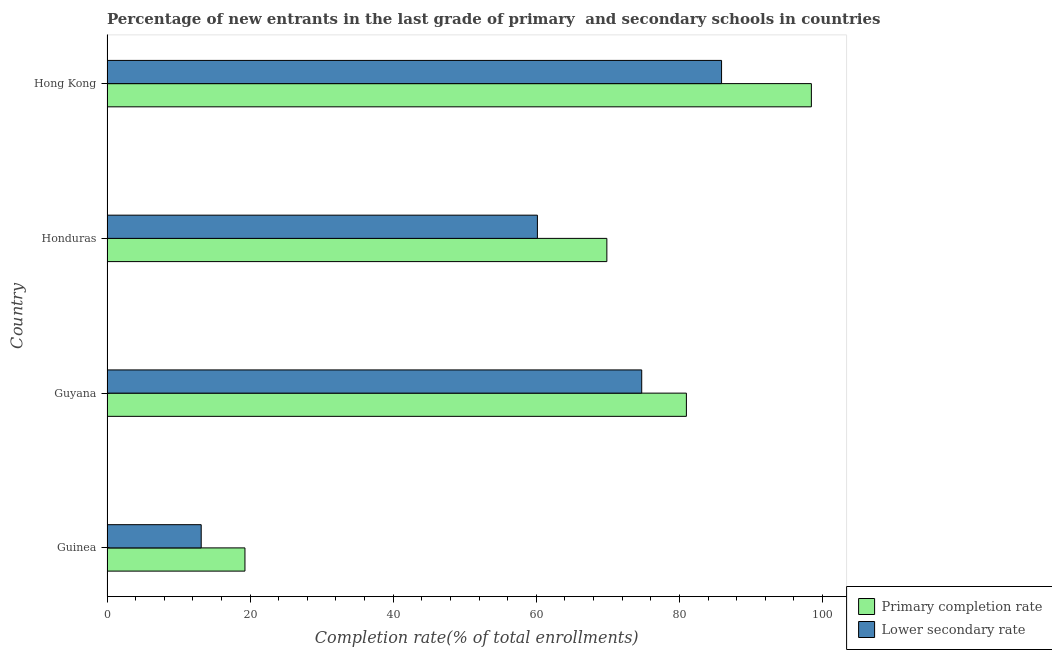How many groups of bars are there?
Offer a terse response. 4. Are the number of bars per tick equal to the number of legend labels?
Keep it short and to the point. Yes. Are the number of bars on each tick of the Y-axis equal?
Your answer should be compact. Yes. What is the label of the 1st group of bars from the top?
Offer a very short reply. Hong Kong. What is the completion rate in secondary schools in Guinea?
Your answer should be very brief. 13.16. Across all countries, what is the maximum completion rate in secondary schools?
Give a very brief answer. 85.88. Across all countries, what is the minimum completion rate in primary schools?
Provide a short and direct response. 19.28. In which country was the completion rate in secondary schools maximum?
Your answer should be very brief. Hong Kong. In which country was the completion rate in primary schools minimum?
Your response must be concise. Guinea. What is the total completion rate in secondary schools in the graph?
Your response must be concise. 233.92. What is the difference between the completion rate in primary schools in Guyana and that in Hong Kong?
Offer a very short reply. -17.46. What is the difference between the completion rate in secondary schools in Hong Kong and the completion rate in primary schools in Guinea?
Ensure brevity in your answer.  66.61. What is the average completion rate in secondary schools per country?
Your response must be concise. 58.48. What is the difference between the completion rate in secondary schools and completion rate in primary schools in Guyana?
Ensure brevity in your answer.  -6.24. What is the ratio of the completion rate in secondary schools in Honduras to that in Hong Kong?
Your response must be concise. 0.7. Is the completion rate in secondary schools in Guinea less than that in Hong Kong?
Provide a succinct answer. Yes. What is the difference between the highest and the second highest completion rate in primary schools?
Ensure brevity in your answer.  17.46. What is the difference between the highest and the lowest completion rate in secondary schools?
Offer a very short reply. 72.72. Is the sum of the completion rate in primary schools in Honduras and Hong Kong greater than the maximum completion rate in secondary schools across all countries?
Offer a terse response. Yes. What does the 1st bar from the top in Hong Kong represents?
Offer a very short reply. Lower secondary rate. What does the 1st bar from the bottom in Guinea represents?
Provide a short and direct response. Primary completion rate. How many bars are there?
Your answer should be very brief. 8. Are all the bars in the graph horizontal?
Ensure brevity in your answer.  Yes. How many countries are there in the graph?
Provide a succinct answer. 4. What is the difference between two consecutive major ticks on the X-axis?
Your response must be concise. 20. Are the values on the major ticks of X-axis written in scientific E-notation?
Your answer should be very brief. No. Does the graph contain any zero values?
Your answer should be compact. No. Where does the legend appear in the graph?
Make the answer very short. Bottom right. How are the legend labels stacked?
Offer a very short reply. Vertical. What is the title of the graph?
Your response must be concise. Percentage of new entrants in the last grade of primary  and secondary schools in countries. What is the label or title of the X-axis?
Make the answer very short. Completion rate(% of total enrollments). What is the Completion rate(% of total enrollments) in Primary completion rate in Guinea?
Your answer should be very brief. 19.28. What is the Completion rate(% of total enrollments) in Lower secondary rate in Guinea?
Your response must be concise. 13.16. What is the Completion rate(% of total enrollments) in Primary completion rate in Guyana?
Offer a very short reply. 80.97. What is the Completion rate(% of total enrollments) of Lower secondary rate in Guyana?
Provide a short and direct response. 74.73. What is the Completion rate(% of total enrollments) in Primary completion rate in Honduras?
Give a very brief answer. 69.85. What is the Completion rate(% of total enrollments) of Lower secondary rate in Honduras?
Your answer should be compact. 60.15. What is the Completion rate(% of total enrollments) of Primary completion rate in Hong Kong?
Your response must be concise. 98.44. What is the Completion rate(% of total enrollments) of Lower secondary rate in Hong Kong?
Keep it short and to the point. 85.88. Across all countries, what is the maximum Completion rate(% of total enrollments) in Primary completion rate?
Give a very brief answer. 98.44. Across all countries, what is the maximum Completion rate(% of total enrollments) in Lower secondary rate?
Give a very brief answer. 85.88. Across all countries, what is the minimum Completion rate(% of total enrollments) of Primary completion rate?
Your response must be concise. 19.28. Across all countries, what is the minimum Completion rate(% of total enrollments) in Lower secondary rate?
Keep it short and to the point. 13.16. What is the total Completion rate(% of total enrollments) in Primary completion rate in the graph?
Ensure brevity in your answer.  268.54. What is the total Completion rate(% of total enrollments) of Lower secondary rate in the graph?
Ensure brevity in your answer.  233.92. What is the difference between the Completion rate(% of total enrollments) in Primary completion rate in Guinea and that in Guyana?
Offer a terse response. -61.69. What is the difference between the Completion rate(% of total enrollments) in Lower secondary rate in Guinea and that in Guyana?
Keep it short and to the point. -61.56. What is the difference between the Completion rate(% of total enrollments) of Primary completion rate in Guinea and that in Honduras?
Offer a very short reply. -50.58. What is the difference between the Completion rate(% of total enrollments) of Lower secondary rate in Guinea and that in Honduras?
Give a very brief answer. -46.98. What is the difference between the Completion rate(% of total enrollments) in Primary completion rate in Guinea and that in Hong Kong?
Offer a terse response. -79.16. What is the difference between the Completion rate(% of total enrollments) in Lower secondary rate in Guinea and that in Hong Kong?
Provide a short and direct response. -72.72. What is the difference between the Completion rate(% of total enrollments) in Primary completion rate in Guyana and that in Honduras?
Your answer should be compact. 11.12. What is the difference between the Completion rate(% of total enrollments) in Lower secondary rate in Guyana and that in Honduras?
Keep it short and to the point. 14.58. What is the difference between the Completion rate(% of total enrollments) in Primary completion rate in Guyana and that in Hong Kong?
Make the answer very short. -17.47. What is the difference between the Completion rate(% of total enrollments) of Lower secondary rate in Guyana and that in Hong Kong?
Offer a very short reply. -11.16. What is the difference between the Completion rate(% of total enrollments) of Primary completion rate in Honduras and that in Hong Kong?
Offer a terse response. -28.58. What is the difference between the Completion rate(% of total enrollments) of Lower secondary rate in Honduras and that in Hong Kong?
Ensure brevity in your answer.  -25.74. What is the difference between the Completion rate(% of total enrollments) in Primary completion rate in Guinea and the Completion rate(% of total enrollments) in Lower secondary rate in Guyana?
Your answer should be compact. -55.45. What is the difference between the Completion rate(% of total enrollments) in Primary completion rate in Guinea and the Completion rate(% of total enrollments) in Lower secondary rate in Honduras?
Your answer should be compact. -40.87. What is the difference between the Completion rate(% of total enrollments) of Primary completion rate in Guinea and the Completion rate(% of total enrollments) of Lower secondary rate in Hong Kong?
Make the answer very short. -66.61. What is the difference between the Completion rate(% of total enrollments) of Primary completion rate in Guyana and the Completion rate(% of total enrollments) of Lower secondary rate in Honduras?
Offer a very short reply. 20.82. What is the difference between the Completion rate(% of total enrollments) of Primary completion rate in Guyana and the Completion rate(% of total enrollments) of Lower secondary rate in Hong Kong?
Give a very brief answer. -4.91. What is the difference between the Completion rate(% of total enrollments) of Primary completion rate in Honduras and the Completion rate(% of total enrollments) of Lower secondary rate in Hong Kong?
Provide a succinct answer. -16.03. What is the average Completion rate(% of total enrollments) of Primary completion rate per country?
Make the answer very short. 67.13. What is the average Completion rate(% of total enrollments) of Lower secondary rate per country?
Keep it short and to the point. 58.48. What is the difference between the Completion rate(% of total enrollments) in Primary completion rate and Completion rate(% of total enrollments) in Lower secondary rate in Guinea?
Give a very brief answer. 6.11. What is the difference between the Completion rate(% of total enrollments) in Primary completion rate and Completion rate(% of total enrollments) in Lower secondary rate in Guyana?
Make the answer very short. 6.24. What is the difference between the Completion rate(% of total enrollments) of Primary completion rate and Completion rate(% of total enrollments) of Lower secondary rate in Honduras?
Offer a very short reply. 9.7. What is the difference between the Completion rate(% of total enrollments) in Primary completion rate and Completion rate(% of total enrollments) in Lower secondary rate in Hong Kong?
Ensure brevity in your answer.  12.55. What is the ratio of the Completion rate(% of total enrollments) in Primary completion rate in Guinea to that in Guyana?
Offer a very short reply. 0.24. What is the ratio of the Completion rate(% of total enrollments) in Lower secondary rate in Guinea to that in Guyana?
Offer a terse response. 0.18. What is the ratio of the Completion rate(% of total enrollments) in Primary completion rate in Guinea to that in Honduras?
Make the answer very short. 0.28. What is the ratio of the Completion rate(% of total enrollments) of Lower secondary rate in Guinea to that in Honduras?
Make the answer very short. 0.22. What is the ratio of the Completion rate(% of total enrollments) of Primary completion rate in Guinea to that in Hong Kong?
Give a very brief answer. 0.2. What is the ratio of the Completion rate(% of total enrollments) in Lower secondary rate in Guinea to that in Hong Kong?
Offer a very short reply. 0.15. What is the ratio of the Completion rate(% of total enrollments) in Primary completion rate in Guyana to that in Honduras?
Offer a very short reply. 1.16. What is the ratio of the Completion rate(% of total enrollments) in Lower secondary rate in Guyana to that in Honduras?
Provide a short and direct response. 1.24. What is the ratio of the Completion rate(% of total enrollments) in Primary completion rate in Guyana to that in Hong Kong?
Offer a terse response. 0.82. What is the ratio of the Completion rate(% of total enrollments) of Lower secondary rate in Guyana to that in Hong Kong?
Provide a succinct answer. 0.87. What is the ratio of the Completion rate(% of total enrollments) in Primary completion rate in Honduras to that in Hong Kong?
Make the answer very short. 0.71. What is the ratio of the Completion rate(% of total enrollments) of Lower secondary rate in Honduras to that in Hong Kong?
Your response must be concise. 0.7. What is the difference between the highest and the second highest Completion rate(% of total enrollments) of Primary completion rate?
Make the answer very short. 17.47. What is the difference between the highest and the second highest Completion rate(% of total enrollments) in Lower secondary rate?
Keep it short and to the point. 11.16. What is the difference between the highest and the lowest Completion rate(% of total enrollments) of Primary completion rate?
Give a very brief answer. 79.16. What is the difference between the highest and the lowest Completion rate(% of total enrollments) of Lower secondary rate?
Provide a succinct answer. 72.72. 